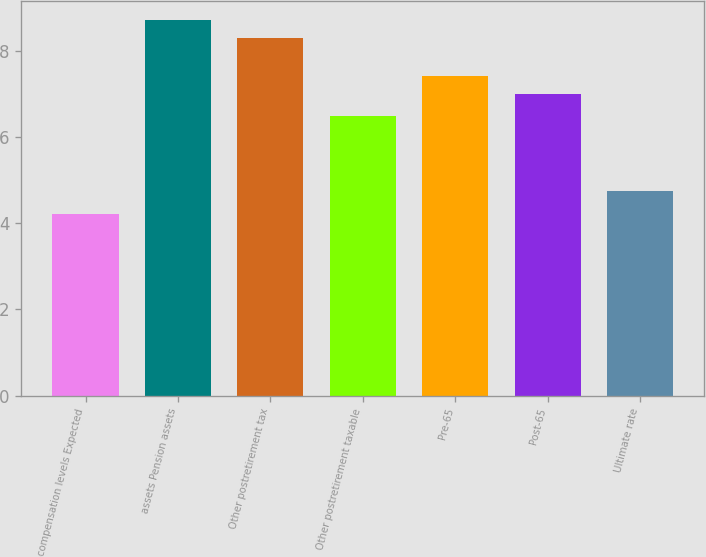Convert chart. <chart><loc_0><loc_0><loc_500><loc_500><bar_chart><fcel>compensation levels Expected<fcel>assets Pension assets<fcel>Other postretirement tax<fcel>Other postretirement taxable<fcel>Pre-65<fcel>Post-65<fcel>Ultimate rate<nl><fcel>4.23<fcel>8.73<fcel>8.3<fcel>6.5<fcel>7.43<fcel>7<fcel>4.75<nl></chart> 